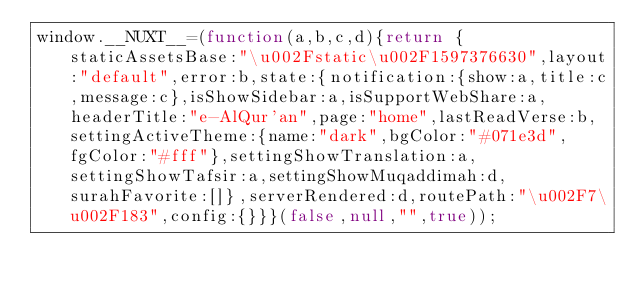Convert code to text. <code><loc_0><loc_0><loc_500><loc_500><_JavaScript_>window.__NUXT__=(function(a,b,c,d){return {staticAssetsBase:"\u002Fstatic\u002F1597376630",layout:"default",error:b,state:{notification:{show:a,title:c,message:c},isShowSidebar:a,isSupportWebShare:a,headerTitle:"e-AlQur'an",page:"home",lastReadVerse:b,settingActiveTheme:{name:"dark",bgColor:"#071e3d",fgColor:"#fff"},settingShowTranslation:a,settingShowTafsir:a,settingShowMuqaddimah:d,surahFavorite:[]},serverRendered:d,routePath:"\u002F7\u002F183",config:{}}}(false,null,"",true));</code> 